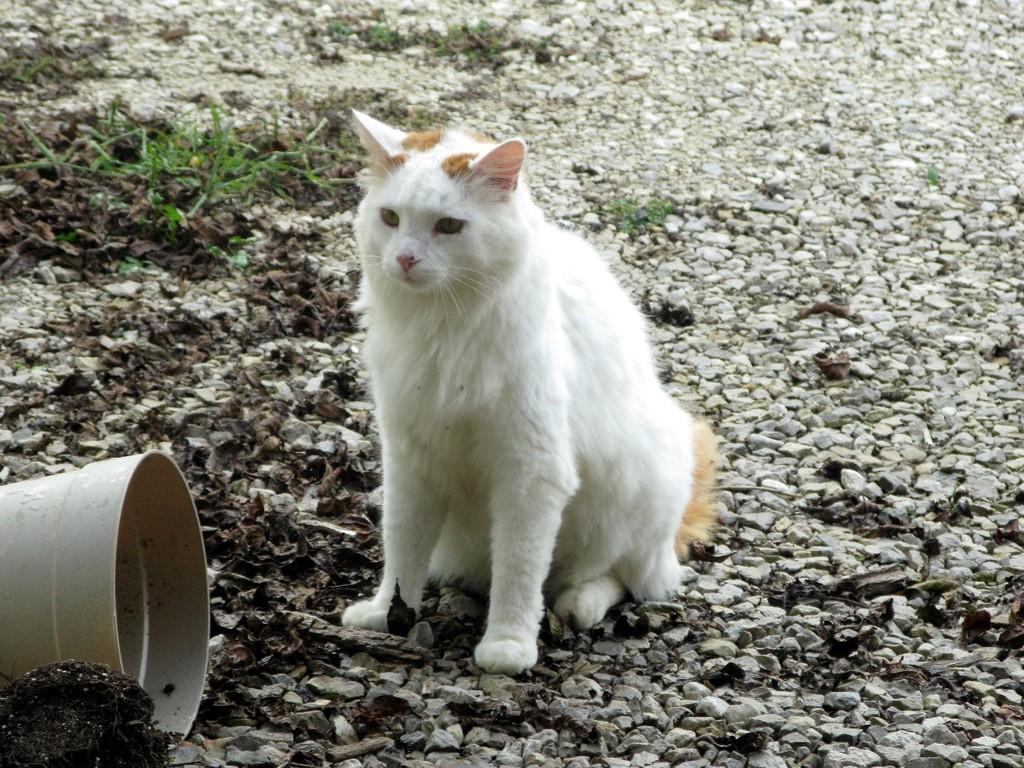Could you give a brief overview of what you see in this image? In this image I can see a white colour cat over here. I can also see grass and a bucket. 